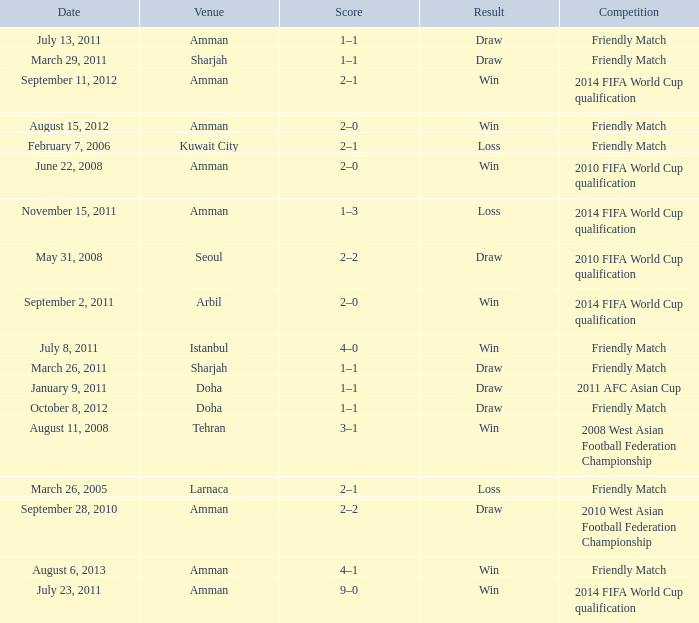What was the name of the competition that took place on may 31, 2008? 2010 FIFA World Cup qualification. 